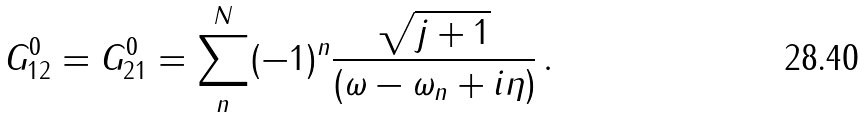Convert formula to latex. <formula><loc_0><loc_0><loc_500><loc_500>G _ { 1 2 } ^ { 0 } = G _ { 2 1 } ^ { 0 } = \sum _ { n } ^ { N } ( - 1 ) ^ { n } \frac { \sqrt { j + 1 } } { ( \omega - \omega _ { n } + i \eta ) } \, .</formula> 